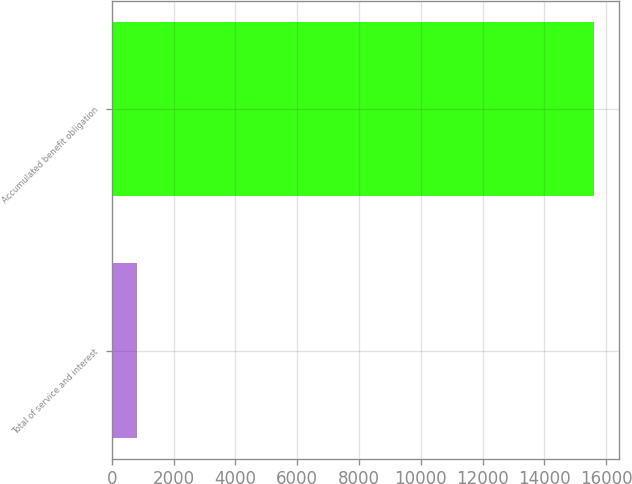Convert chart to OTSL. <chart><loc_0><loc_0><loc_500><loc_500><bar_chart><fcel>Total of service and interest<fcel>Accumulated benefit obligation<nl><fcel>824<fcel>15616<nl></chart> 